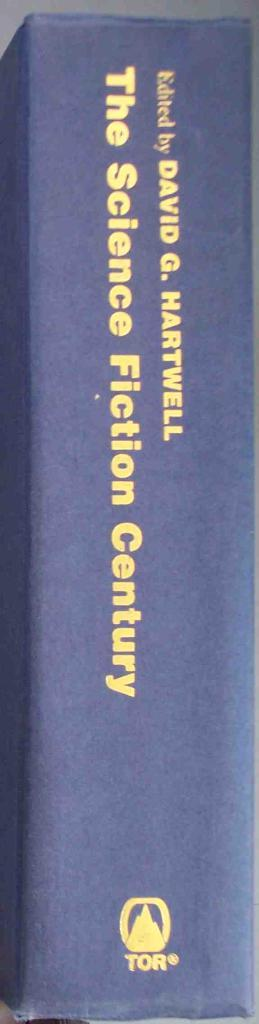Provide a one-sentence caption for the provided image. The book The Science Fiction Century was edited by David G. Hartwell. 